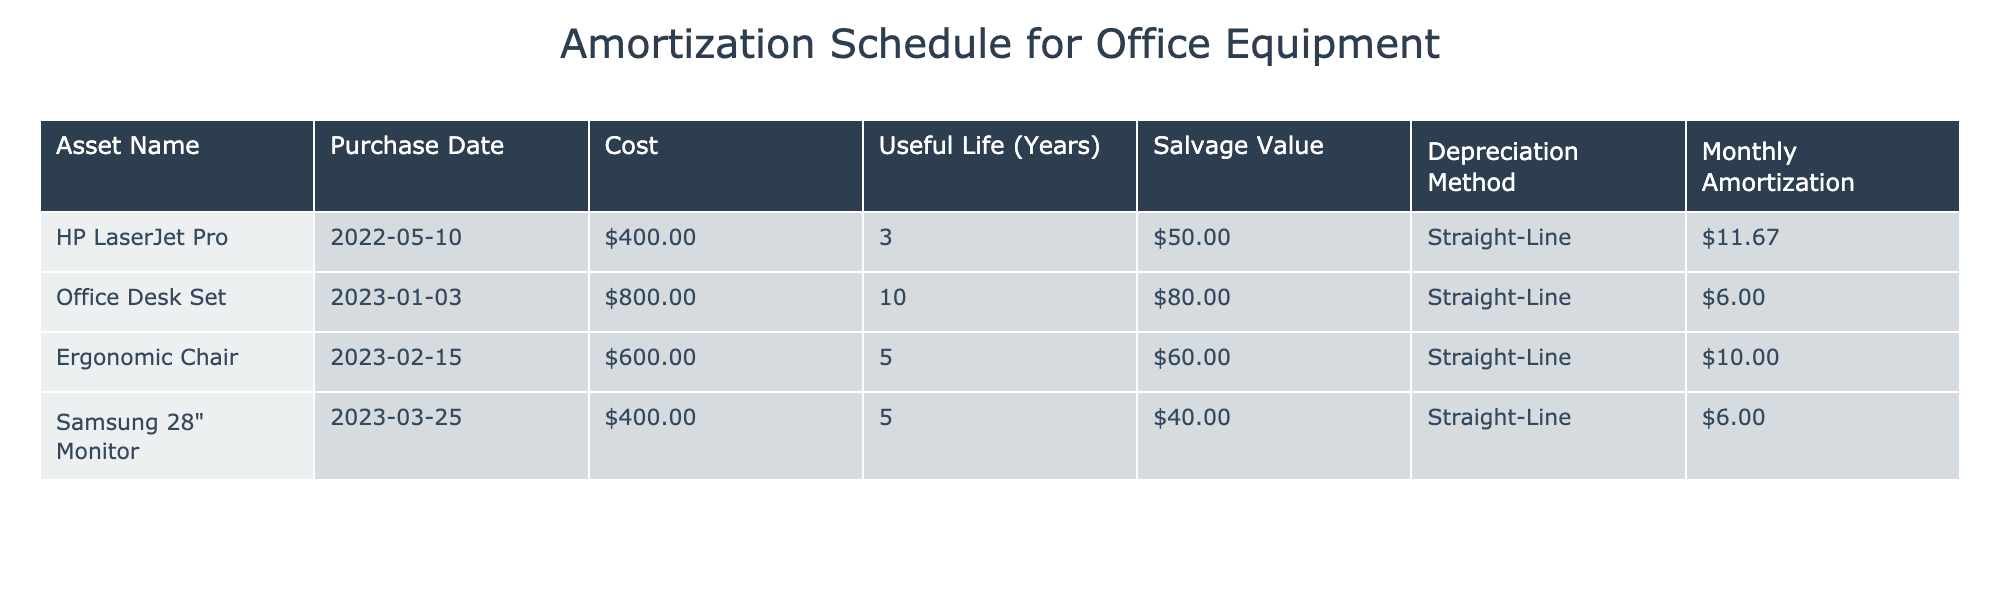What is the total cost of the HP LaserJet Pro? The cost of the HP LaserJet Pro is listed in the table as $400.00.
Answer: $400.00 What is the salvage value of the Ergonomic Chair? The salvage value of the Ergonomic Chair is indicated in the table as $60.00.
Answer: $60.00 Which asset has the highest monthly amortization? The monthly amortization values are $11.67 for HP LaserJet Pro, $6.00 for Office Desk Set, $10.00 for Ergonomic Chair, and $6.00 for Samsung 28" Monitor. The highest value is $11.67 for HP LaserJet Pro.
Answer: HP LaserJet Pro What is the average useful life of all the assets listed? The useful lives are 3, 10, 5, and 5 years. Adding these together gives 3 + 10 + 5 + 5 = 23 years. Dividing by the number of assets (4) gives 23/4 = 5.75 years.
Answer: 5.75 years Is the Office Desk Set's monthly amortization less than the sum of the monthly amortization of the other assets? The monthly amortization of the Office Desk Set is $6.00. The total of the monthly amortization for the other assets is $11.67 + $10.00 + $6.00 = $27.67. Since $6.00 is less than $27.67, the statement is true.
Answer: Yes How much total monthly amortization do all the assets generate together? The monthly amortization values are $11.67, $6.00, $10.00, and $6.00. Adding them gives $11.67 + $6.00 + $10.00 + $6.00 = $33.67.
Answer: $33.67 Is there an asset with a salvage value greater than its monthly amortization? The salvage values are $50.00 for HP LaserJet Pro, $80.00 for Office Desk Set, $60.00 for Ergonomic Chair, and $40.00 for Samsung 28" Monitor. Their respective monthly amortizations are $11.67, $6.00, $10.00, and $6.00. All salvage values are greater than their monthly amortizations, so the statement is true.
Answer: Yes What is the depreciation method used for the Samsung 28" Monitor? The Samsung 28" Monitor is marked in the table as using the Straight-Line depreciation method.
Answer: Straight-Line What is the total cost of the office equipment that has a useful life of 5 years? The assets with a useful life of 5 years are the Ergonomic Chair and Samsung 28" Monitor, costing $600.00 and $400.00, respectively. Adding these gives $600.00 + $400.00 = $1000.00.
Answer: $1000.00 